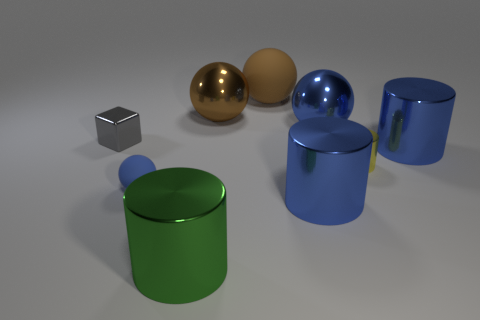Subtract all cylinders. How many objects are left? 5 Add 6 brown things. How many brown things are left? 8 Add 8 green metal cylinders. How many green metal cylinders exist? 9 Subtract 2 blue cylinders. How many objects are left? 7 Subtract all large rubber objects. Subtract all rubber objects. How many objects are left? 6 